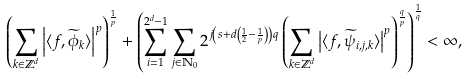<formula> <loc_0><loc_0><loc_500><loc_500>\left ( \sum _ { k \in \mathbb { Z } ^ { d } } \left | \langle f , \widetilde { \phi } _ { k } \rangle \right | ^ { p } \right ) ^ { \frac { 1 } { p } } + \left ( \sum _ { i = 1 } ^ { 2 ^ { d } - 1 } \sum _ { j \in \mathbb { N } _ { 0 } } 2 ^ { j \left ( s + d \left ( \frac { 1 } { 2 } - \frac { 1 } { p } \right ) \right ) q } \left ( \sum _ { k \in \mathbb { Z } ^ { d } } \left | \langle f , \widetilde { \psi } _ { i , j , k } \rangle \right | ^ { p } \right ) ^ { \frac { q } { p } } \right ) ^ { \frac { 1 } { q } } < \infty ,</formula> 